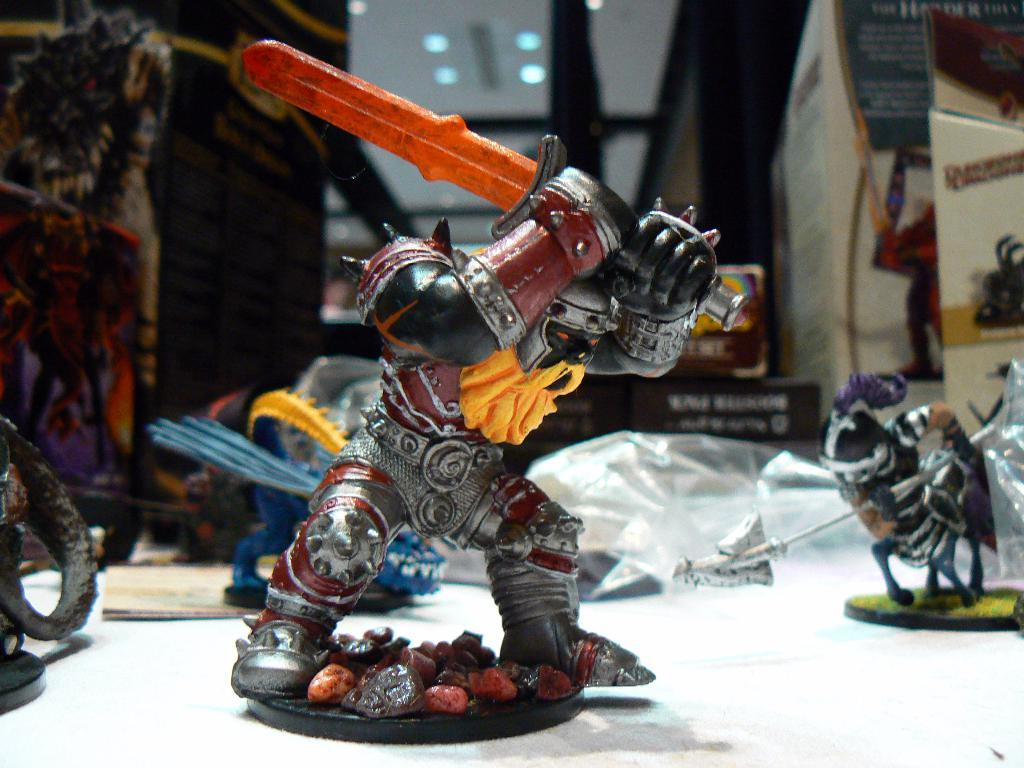What type of toy can be seen in the image? There is a toy soldier in the image. What is the toy soldier holding in its hand? The toy soldier has a sword in its hand. What else can be seen in the image besides the toy soldier? There are other toys, covers, and articles in the image. What type of acoustics can be heard in the image? There is no sound or acoustics present in the image, as it is a still image. 